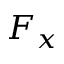Convert formula to latex. <formula><loc_0><loc_0><loc_500><loc_500>F _ { x }</formula> 